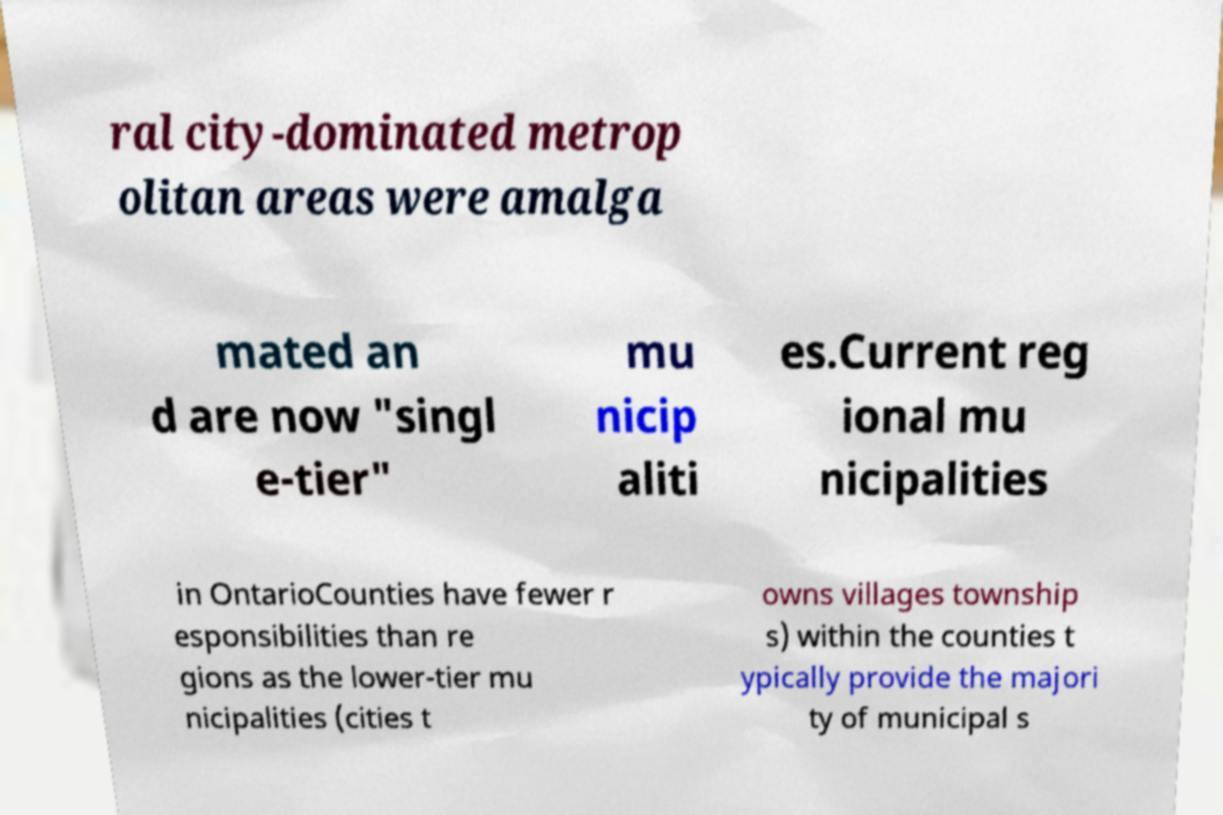There's text embedded in this image that I need extracted. Can you transcribe it verbatim? ral city-dominated metrop olitan areas were amalga mated an d are now "singl e-tier" mu nicip aliti es.Current reg ional mu nicipalities in OntarioCounties have fewer r esponsibilities than re gions as the lower-tier mu nicipalities (cities t owns villages township s) within the counties t ypically provide the majori ty of municipal s 